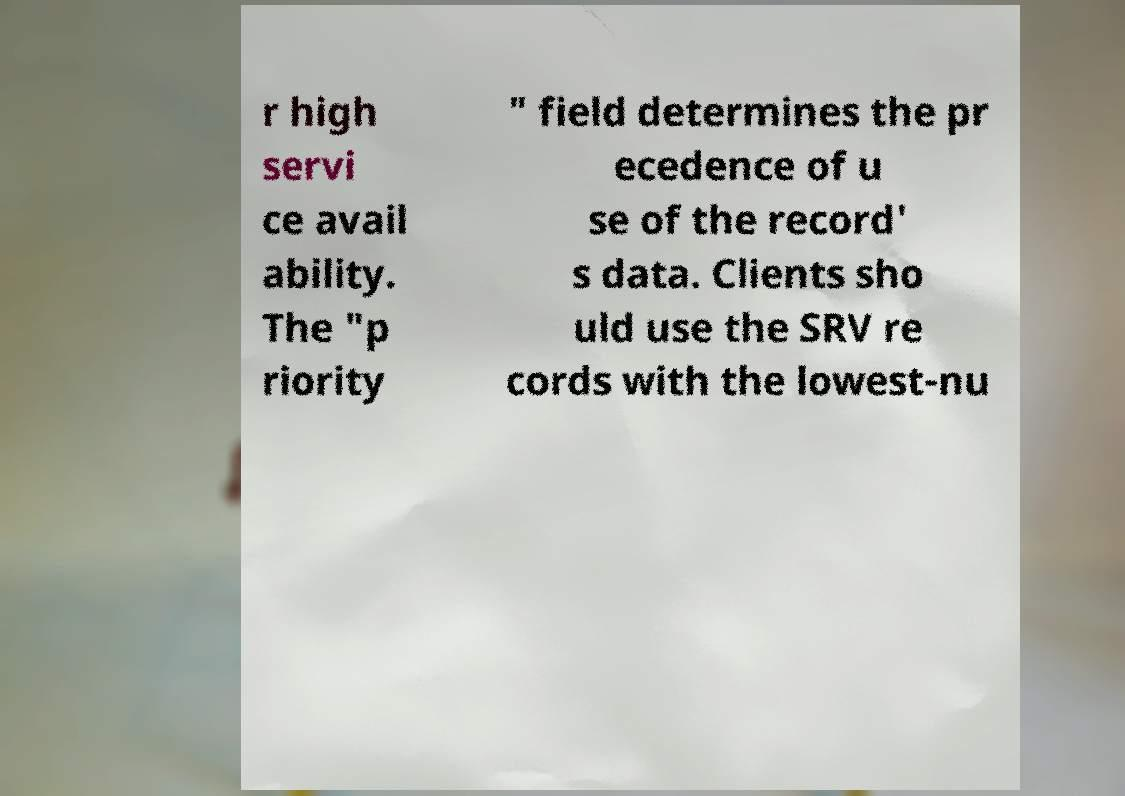Could you assist in decoding the text presented in this image and type it out clearly? r high servi ce avail ability. The "p riority " field determines the pr ecedence of u se of the record' s data. Clients sho uld use the SRV re cords with the lowest-nu 